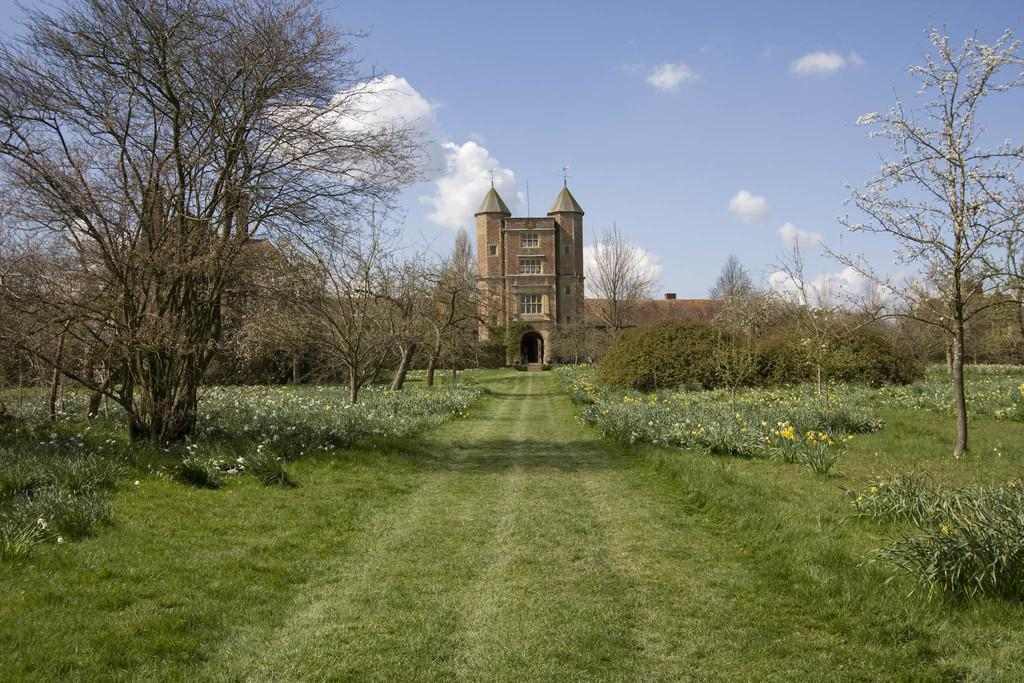What can be seen in the foreground of the image? There is greenery in the foreground of the image. What type of vegetation is present on both sides of the image? There are trees on both sides of the image. What structure is visible in the background of the image? There is a building in the background of the image. How would you describe the sky in the image? The sky is cloudy in the image. What type of balls are being used for hobbies in the image? There are no balls or hobbies mentioned or depicted in the image. 